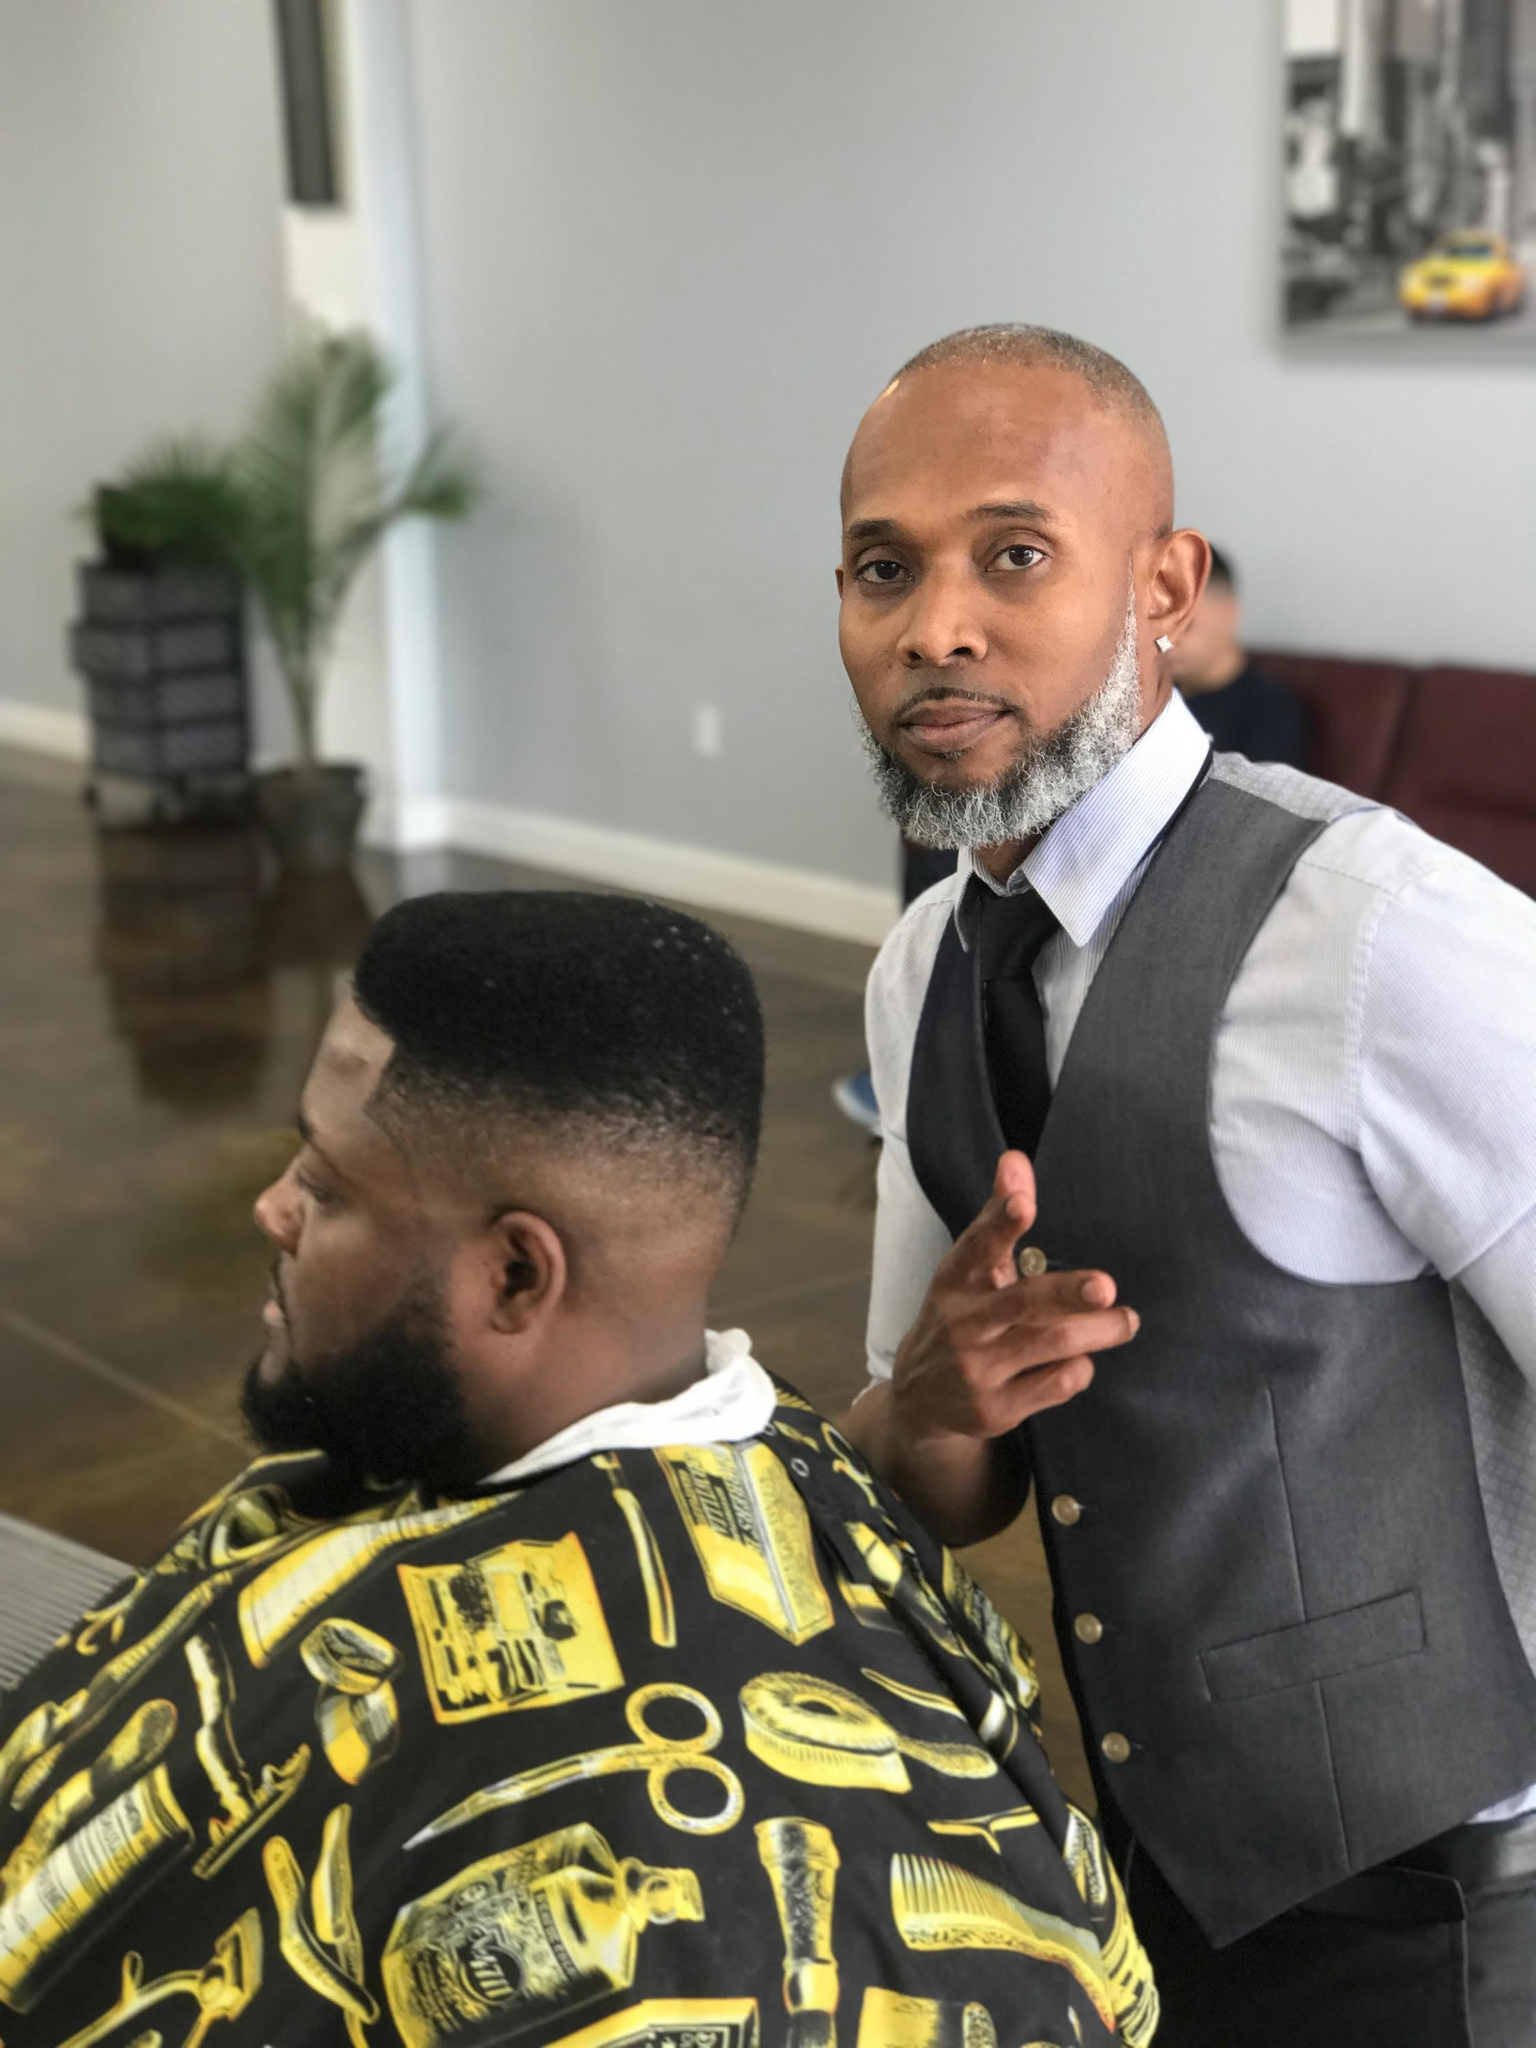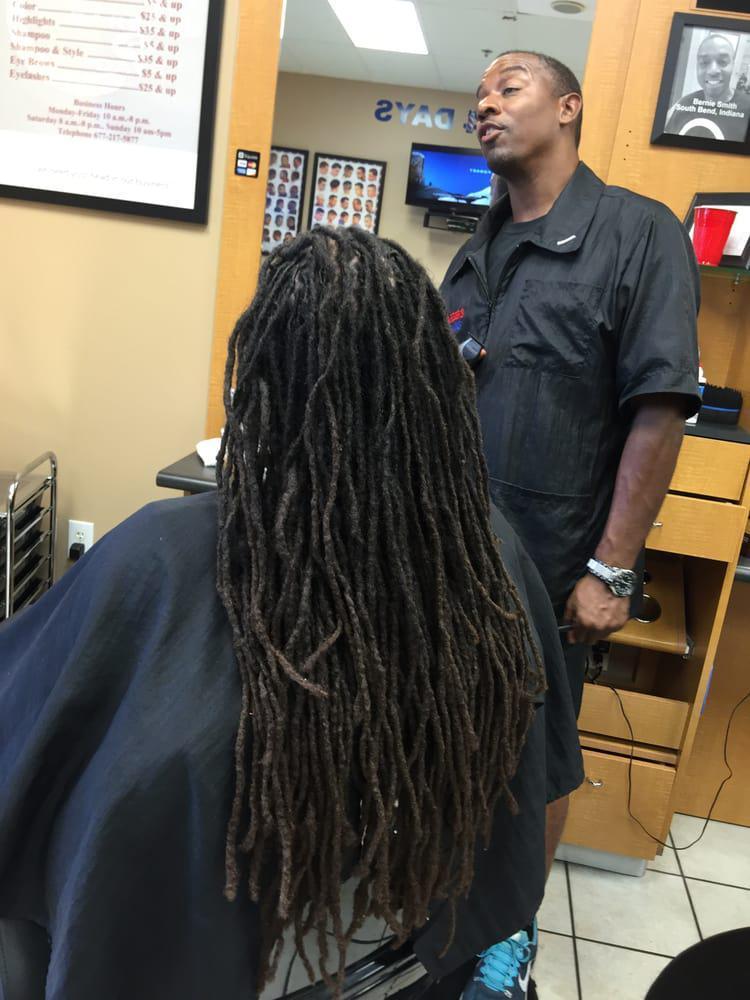The first image is the image on the left, the second image is the image on the right. Considering the images on both sides, is "The left and right image contains the same number of people in the barber shop with at least one being a woman." valid? Answer yes or no. No. 